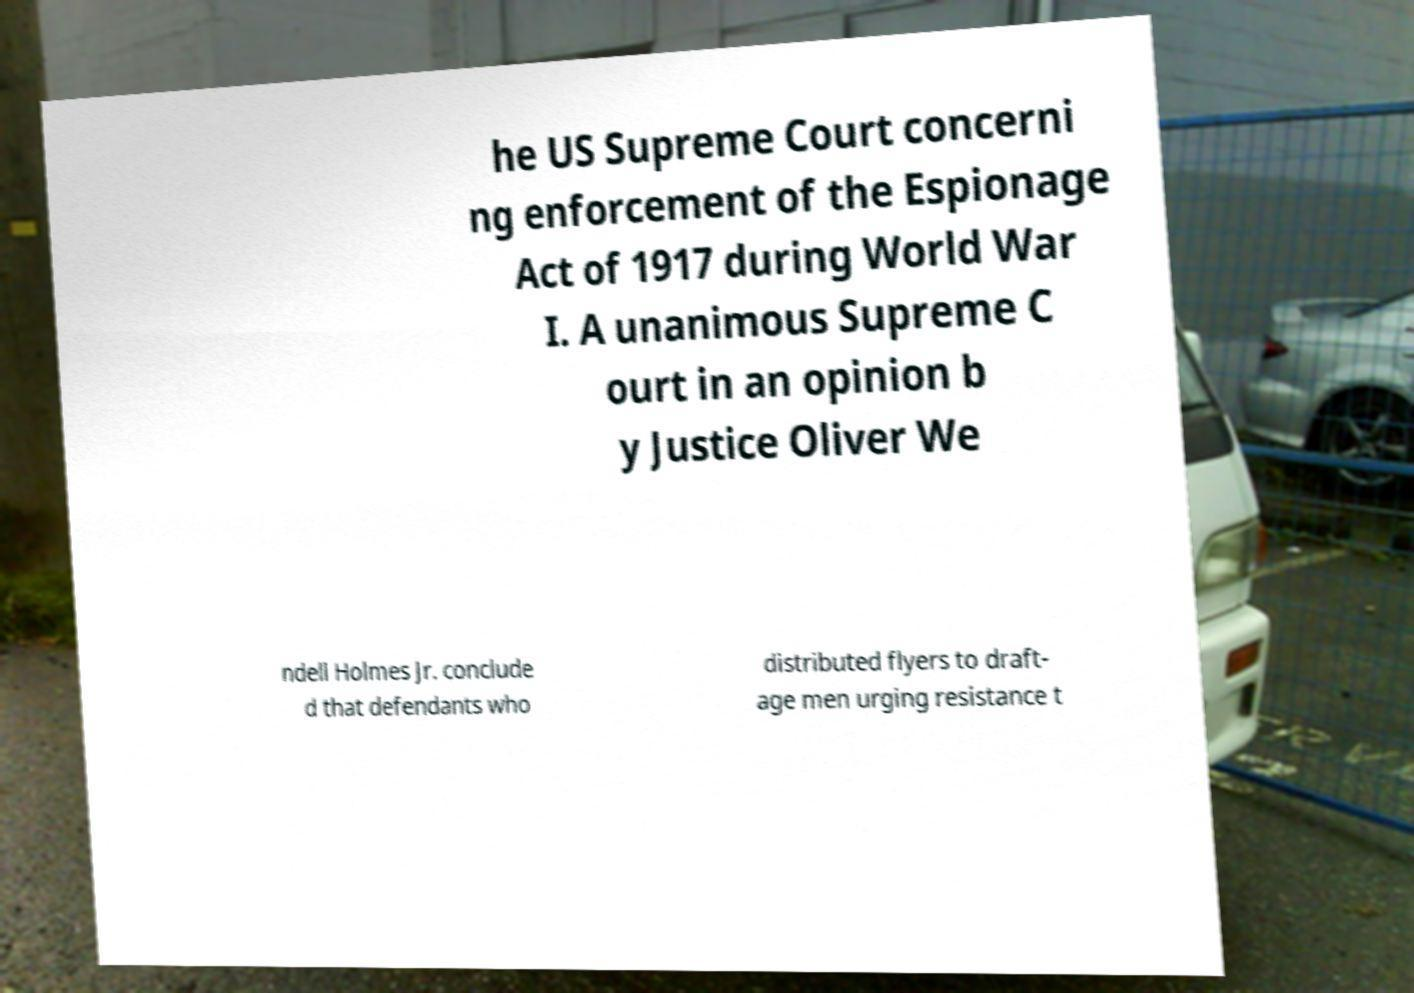What messages or text are displayed in this image? I need them in a readable, typed format. he US Supreme Court concerni ng enforcement of the Espionage Act of 1917 during World War I. A unanimous Supreme C ourt in an opinion b y Justice Oliver We ndell Holmes Jr. conclude d that defendants who distributed flyers to draft- age men urging resistance t 